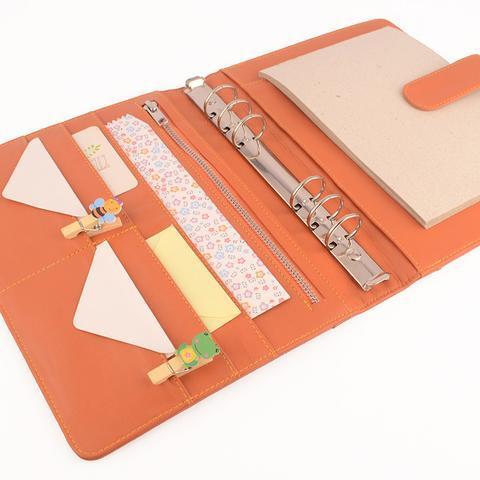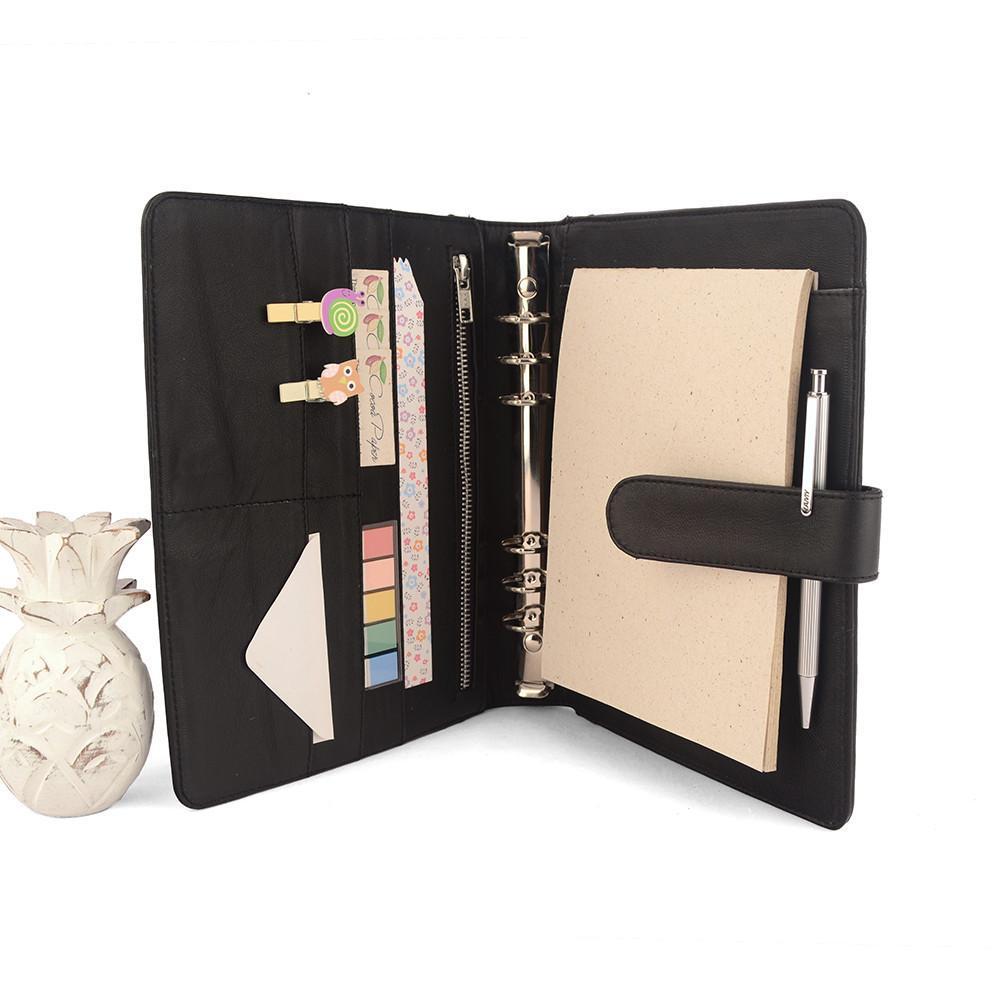The first image is the image on the left, the second image is the image on the right. Given the left and right images, does the statement "In one image, a peach colored notebook is shown in an open position, displaying its contents." hold true? Answer yes or no. Yes. The first image is the image on the left, the second image is the image on the right. Evaluate the accuracy of this statement regarding the images: "One of the binders is gold.". Is it true? Answer yes or no. No. The first image is the image on the left, the second image is the image on the right. Given the left and right images, does the statement "One image shows exactly one open orange binder." hold true? Answer yes or no. Yes. 